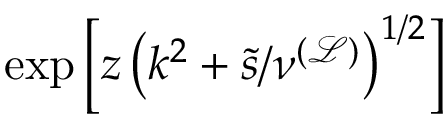<formula> <loc_0><loc_0><loc_500><loc_500>\exp \left [ z \left ( k ^ { 2 } + \tilde { s } / \nu ^ { \mathcal { ( L ) } } \right ) ^ { 1 / 2 } \right ]</formula> 